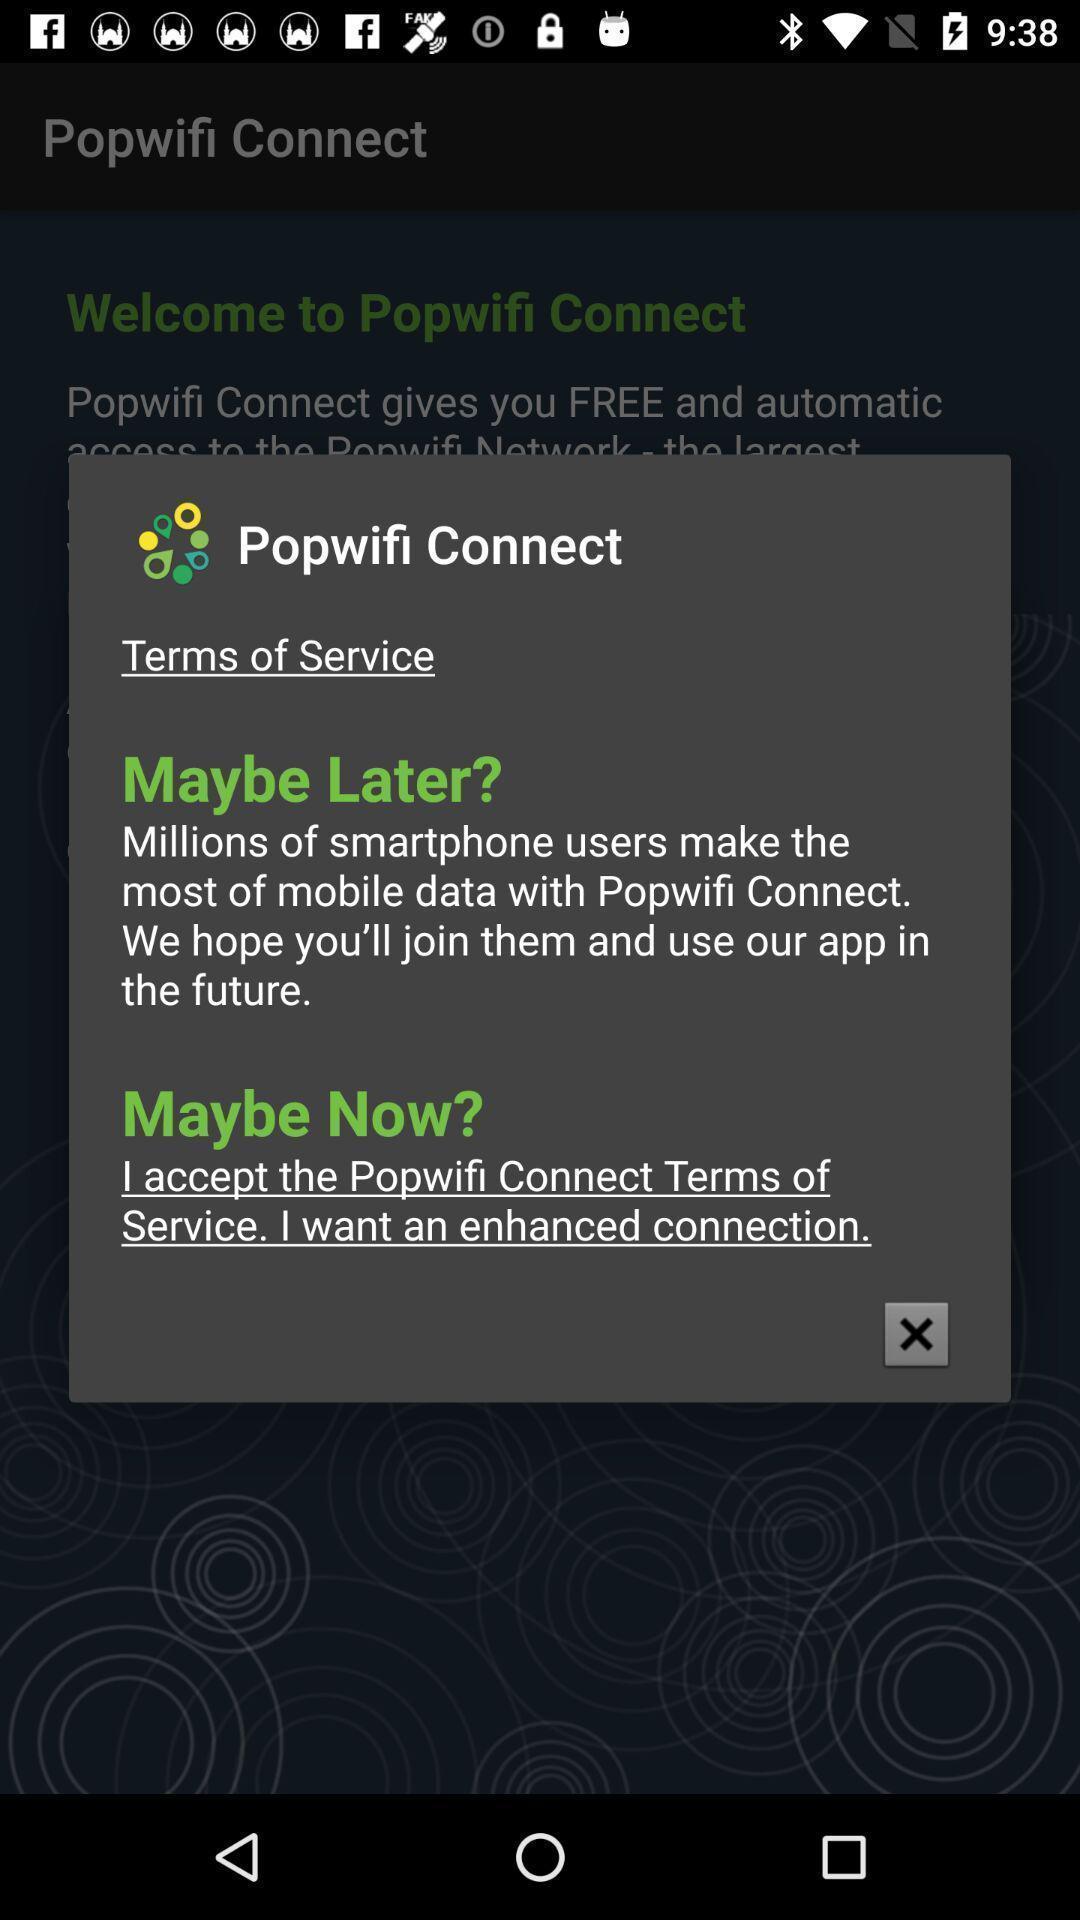Tell me what you see in this picture. Pop-up displaying terms of services. 